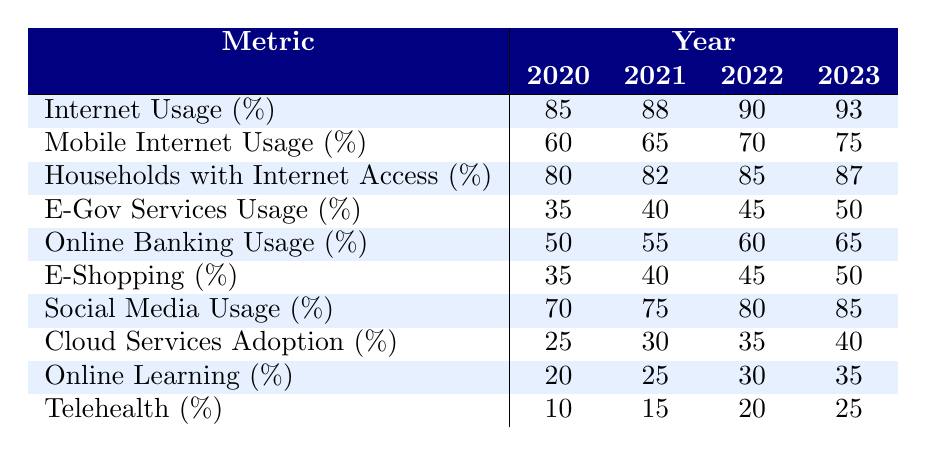What was the internet usage percentage in Slovakia in 2022? According to the table, the internet usage percentage for 2022 is listed as 90%.
Answer: 90% What is the difference in mobile internet usage percentage between 2020 and 2023? The mobile internet usage percentage for 2020 is 60% and for 2023 is 75%. The difference is 75% - 60% = 15%.
Answer: 15% Did the percentage of households with internet access increase or decrease from 2020 to 2023? The percentage of households with internet access increased from 80% in 2020 to 87% in 2023. Therefore, the trend is an increase.
Answer: Yes What was the average online banking usage percentage from 2020 to 2023? The online banking usage percentages for 2020, 2021, 2022, and 2023 are 50%, 55%, 60%, and 65%, respectively. The average is (50 + 55 + 60 + 65) / 4 = 57.5%.
Answer: 57.5% Which service had the lowest adoption percentage in 2020? In 2020, the lowest adoption percentage was for telehealth, which was 10%.
Answer: Telehealth What is the total increase in e-Gov services usage percentage from 2020 to 2023? The e-Gov services usage percentage increased from 35% in 2020 to 50% in 2023, which is a total increase of 50% - 35% = 15%.
Answer: 15% Was social media usage higher than cloud services adoption in 2021? In 2021, social media usage was 75% while cloud services adoption was 30%. Since 75% is higher than 30%, the statement is true.
Answer: Yes How much did the online learning percentage increase from 2020 to 2023? The online learning percentage increased from 20% in 2020 to 35% in 2023. The increase is calculated as 35% - 20% = 15%.
Answer: 15% What percentage of internet usage was recorded in 2020 compared to the percentage of telehealth usage in the same year? In 2020, the internet usage percentage was 85% while the telehealth percentage was 10%. In summary, internet usage was significantly higher.
Answer: Yes (internet usage was higher) Which two services had the same usage percentage in 2022? The e-shopping and e-Gov services usage percentages both recorded 45% in 2022 according to the table.
Answer: E-shopping and e-Gov services 